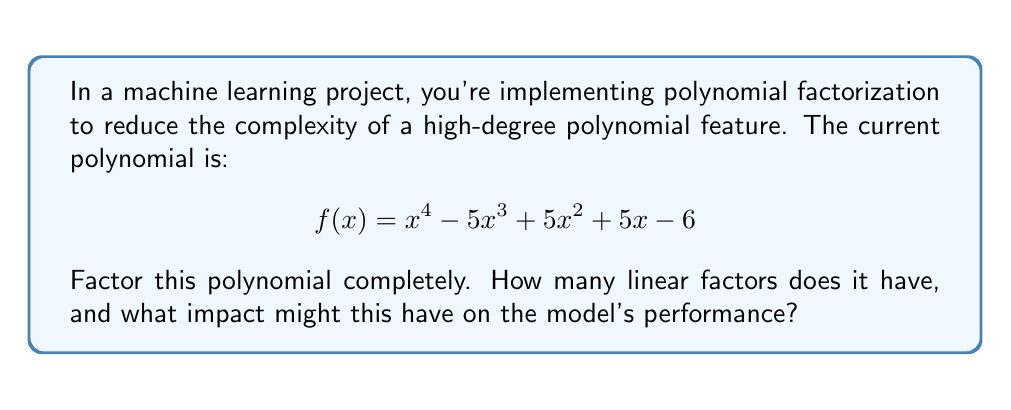Help me with this question. To factor this polynomial, we'll follow these steps:

1) First, check for any common factors. In this case, there are none.

2) Next, check if it's possible to factor by grouping. It's not applicable here.

3) Try to find rational roots using the rational root theorem. The possible rational roots are the factors of the constant term (±1, ±2, ±3, ±6).

4) Testing these values, we find that x = 1 is a root. So (x - 1) is a factor.

5) Divide f(x) by (x - 1):

   $$\frac{x^4 - 5x^3 + 5x^2 + 5x - 6}{x - 1} = x^3 - 4x^2 + x + 6$$

6) Now we have: $f(x) = (x - 1)(x^3 - 4x^2 + x + 6)$

7) The cubic factor can be further factored. Testing rational roots again, we find x = 2 is a root.

8) Dividing $(x^3 - 4x^2 + x + 6)$ by $(x - 2)$:

   $$\frac{x^3 - 4x^2 + x + 6}{x - 2} = x^2 - 2x - 3$$

9) The quadratic factor $x^2 - 2x - 3$ can be factored as $(x - 3)(x + 1)$

Therefore, the complete factorization is:

$$f(x) = (x - 1)(x - 2)(x - 3)(x + 1)$$

The polynomial has 4 linear factors.

Impact on model performance:
1. Reduced complexity: Factorization reduces the degree of individual terms, potentially simplifying the model.
2. Feature interpretability: Linear factors are more interpretable than high-degree polynomials.
3. Numerical stability: Working with lower-degree terms can improve numerical stability in computations.
4. Potential for feature selection: Each factor could be considered as a separate feature, allowing for more granular feature selection.
Answer: 4 linear factors; may reduce complexity, improve interpretability and numerical stability, and enable granular feature selection. 